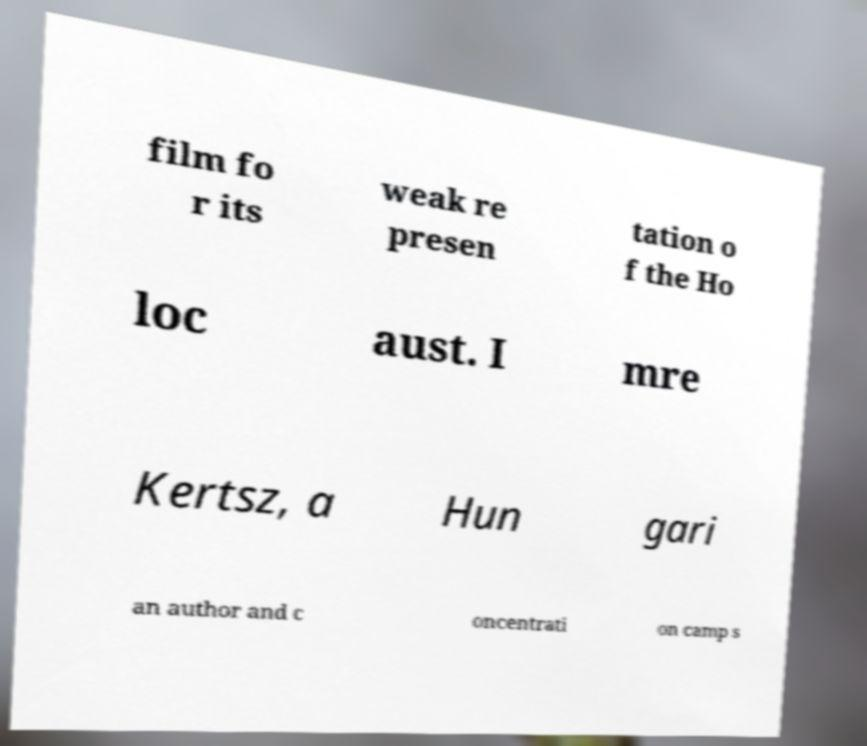Can you accurately transcribe the text from the provided image for me? film fo r its weak re presen tation o f the Ho loc aust. I mre Kertsz, a Hun gari an author and c oncentrati on camp s 